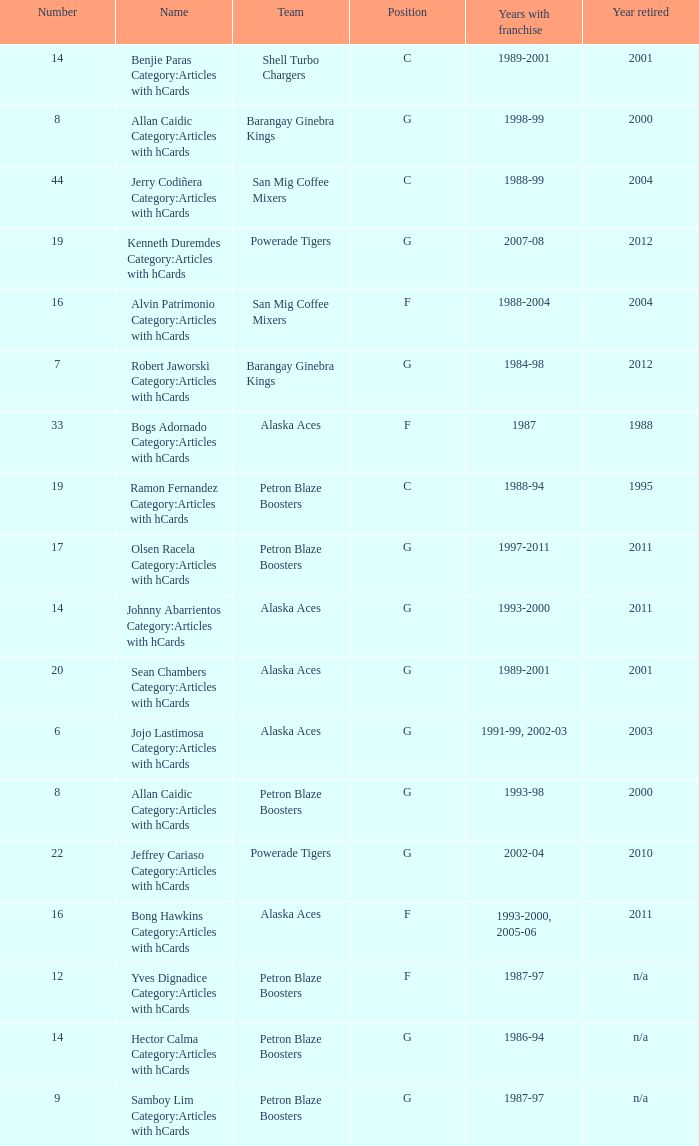Which team is number 14 and had a franchise in 1993-2000? Alaska Aces. 